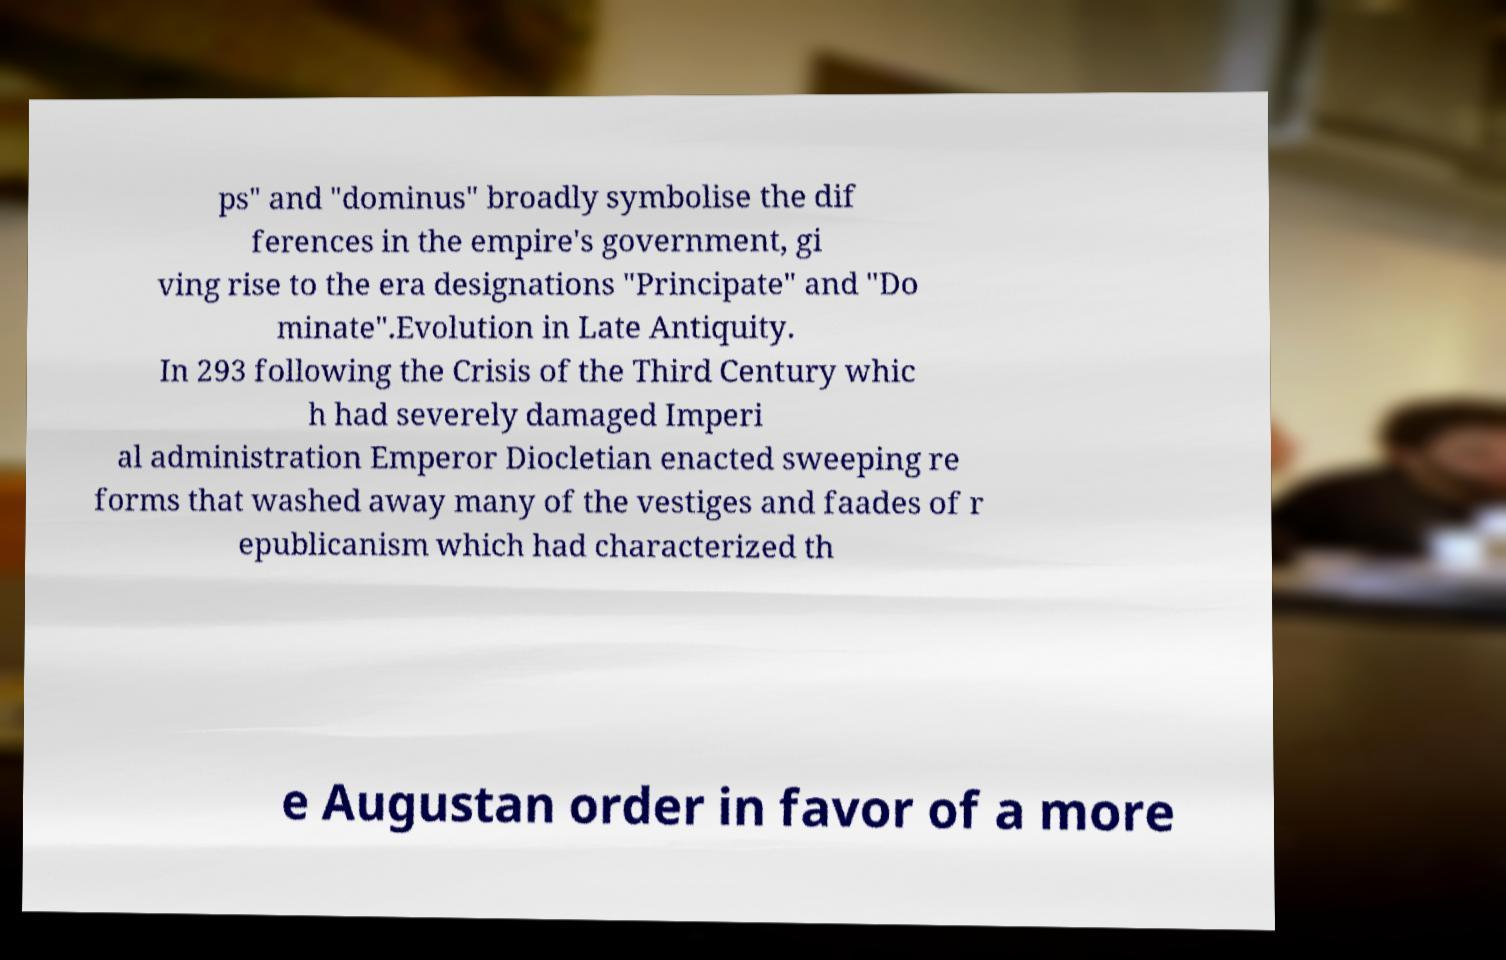What messages or text are displayed in this image? I need them in a readable, typed format. ps" and "dominus" broadly symbolise the dif ferences in the empire's government, gi ving rise to the era designations "Principate" and "Do minate".Evolution in Late Antiquity. In 293 following the Crisis of the Third Century whic h had severely damaged Imperi al administration Emperor Diocletian enacted sweeping re forms that washed away many of the vestiges and faades of r epublicanism which had characterized th e Augustan order in favor of a more 